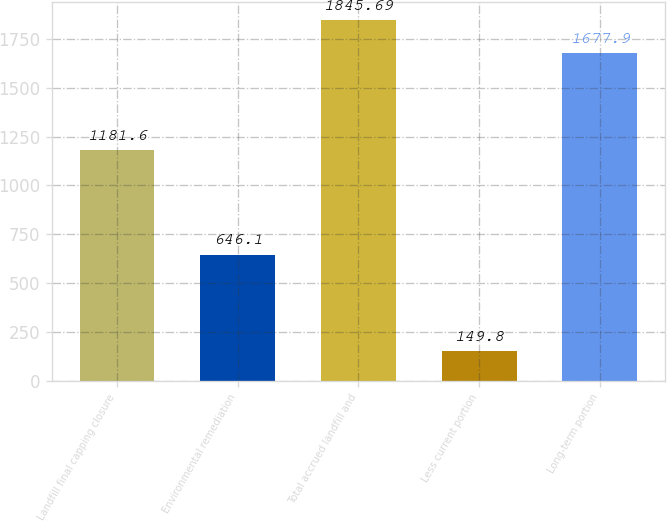<chart> <loc_0><loc_0><loc_500><loc_500><bar_chart><fcel>Landfill final capping closure<fcel>Environmental remediation<fcel>Total accrued landfill and<fcel>Less current portion<fcel>Long-term portion<nl><fcel>1181.6<fcel>646.1<fcel>1845.69<fcel>149.8<fcel>1677.9<nl></chart> 